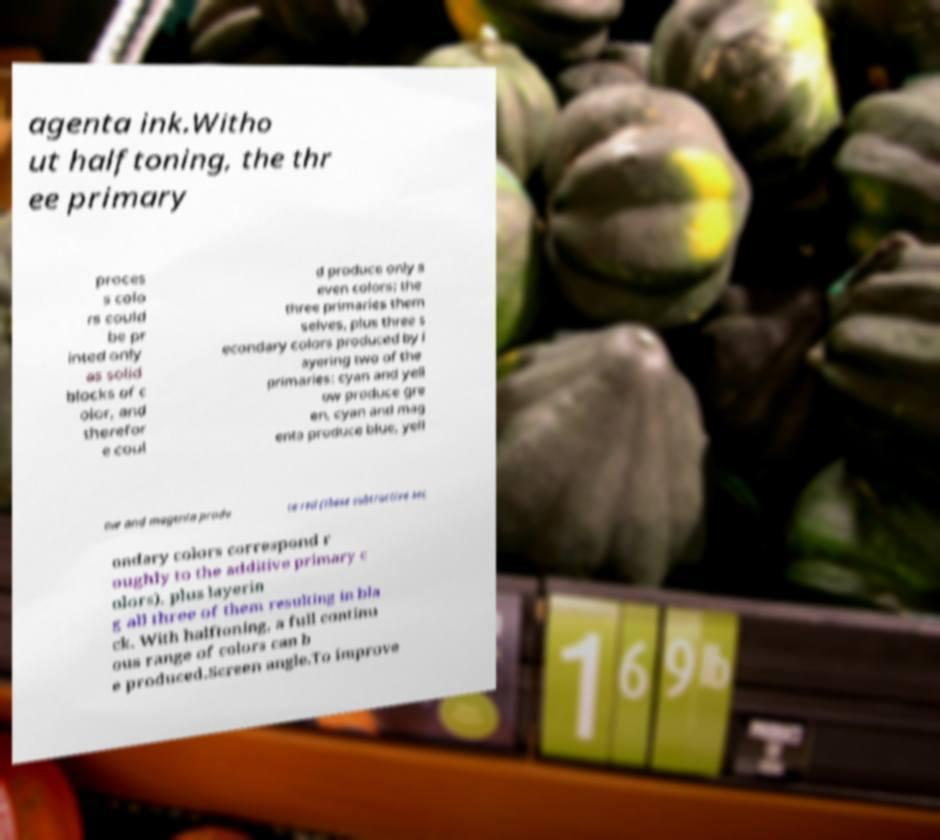For documentation purposes, I need the text within this image transcribed. Could you provide that? agenta ink.Witho ut halftoning, the thr ee primary proces s colo rs could be pr inted only as solid blocks of c olor, and therefor e coul d produce only s even colors: the three primaries them selves, plus three s econdary colors produced by l ayering two of the primaries: cyan and yell ow produce gre en, cyan and mag enta produce blue, yell ow and magenta produ ce red (these subtractive sec ondary colors correspond r oughly to the additive primary c olors), plus layerin g all three of them resulting in bla ck. With halftoning, a full continu ous range of colors can b e produced.Screen angle.To improve 